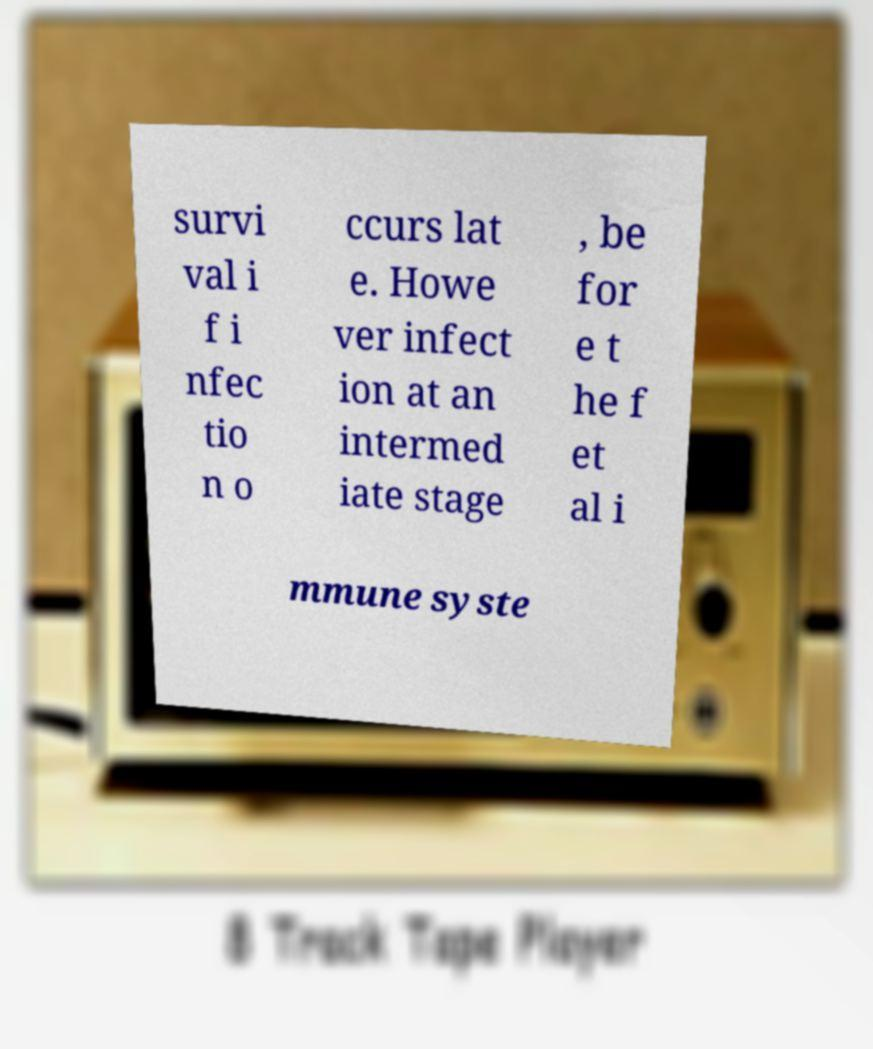Could you assist in decoding the text presented in this image and type it out clearly? survi val i f i nfec tio n o ccurs lat e. Howe ver infect ion at an intermed iate stage , be for e t he f et al i mmune syste 